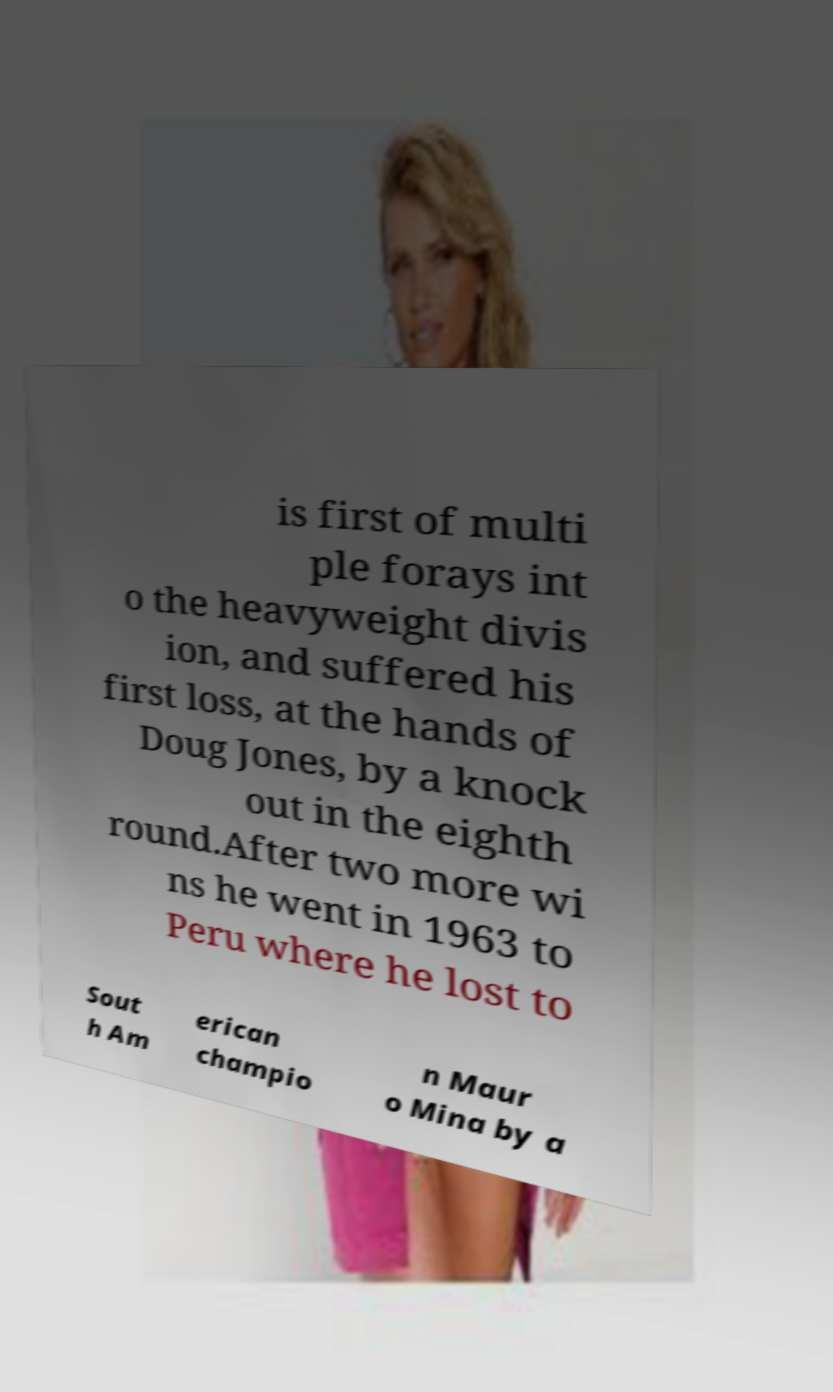Please identify and transcribe the text found in this image. is first of multi ple forays int o the heavyweight divis ion, and suffered his first loss, at the hands of Doug Jones, by a knock out in the eighth round.After two more wi ns he went in 1963 to Peru where he lost to Sout h Am erican champio n Maur o Mina by a 